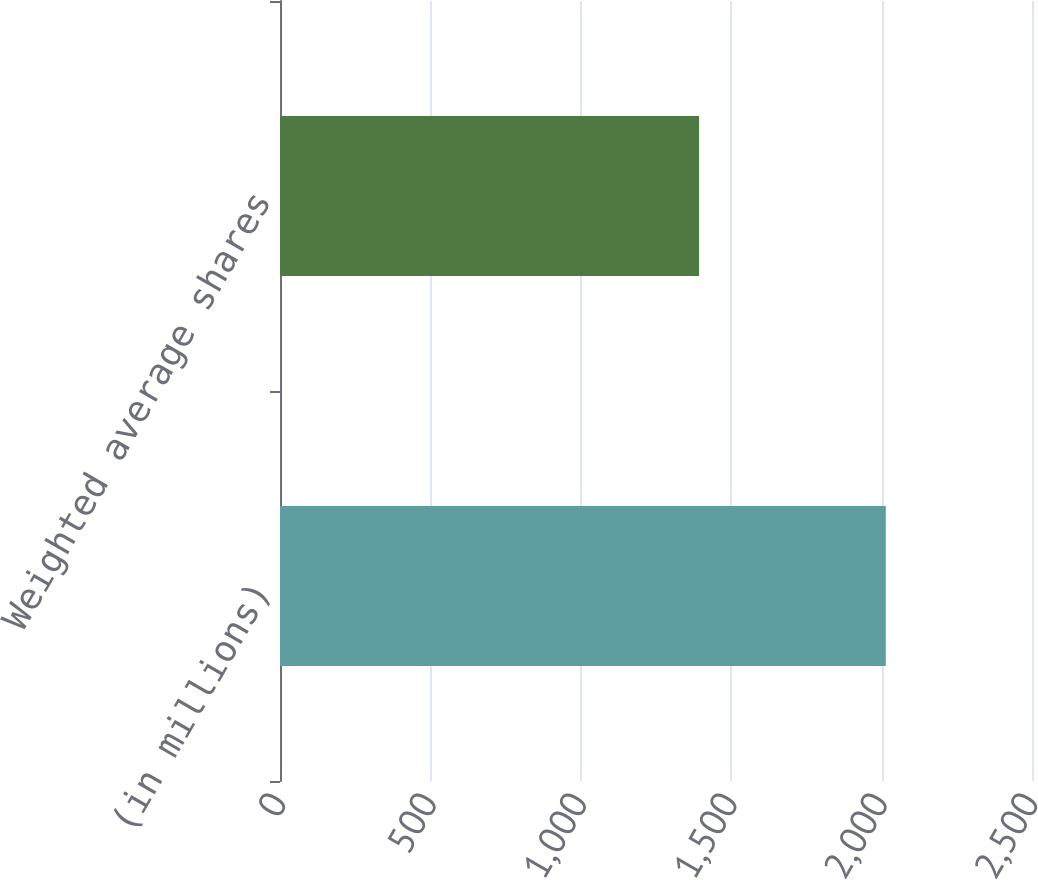<chart> <loc_0><loc_0><loc_500><loc_500><bar_chart><fcel>(in millions)<fcel>Weighted average shares<nl><fcel>2014<fcel>1393.27<nl></chart> 